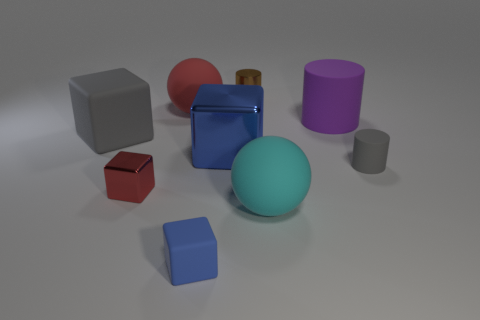What is the cylinder that is left of the cyan object made of?
Keep it short and to the point. Metal. There is a rubber cube that is in front of the tiny gray object; does it have the same color as the big metal thing?
Your answer should be very brief. Yes. There is a red object that is behind the red metal block in front of the tiny metal cylinder; how big is it?
Provide a succinct answer. Large. Are there more metal blocks left of the red matte ball than tiny cyan shiny blocks?
Offer a very short reply. Yes. Do the rubber ball on the left side of the metal cylinder and the brown cylinder have the same size?
Your answer should be very brief. No. There is a metallic thing that is left of the tiny brown metal object and behind the tiny gray object; what color is it?
Give a very brief answer. Blue. There is a blue thing that is the same size as the red cube; what shape is it?
Provide a succinct answer. Cube. Is there a large matte sphere of the same color as the small shiny block?
Your answer should be compact. Yes. Are there the same number of red objects to the left of the large rubber cube and blue matte cylinders?
Your answer should be very brief. Yes. Is the color of the large metallic object the same as the small rubber cube?
Your answer should be compact. Yes. 